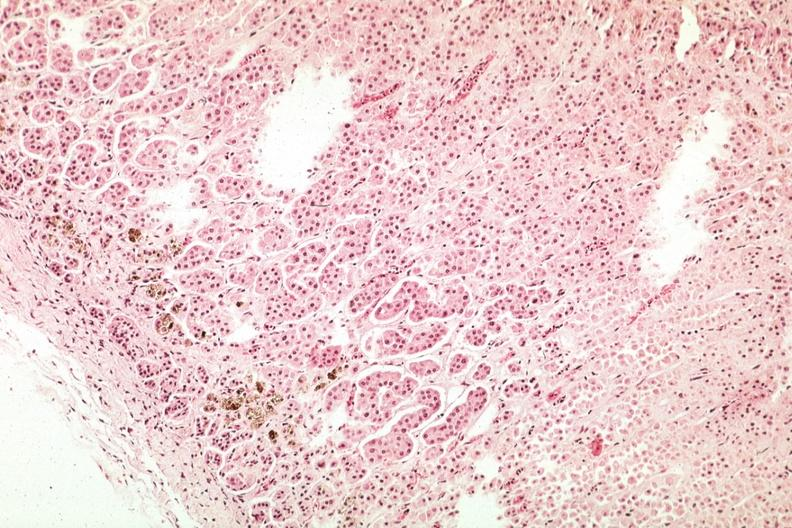what is present?
Answer the question using a single word or phrase. Endocrine 